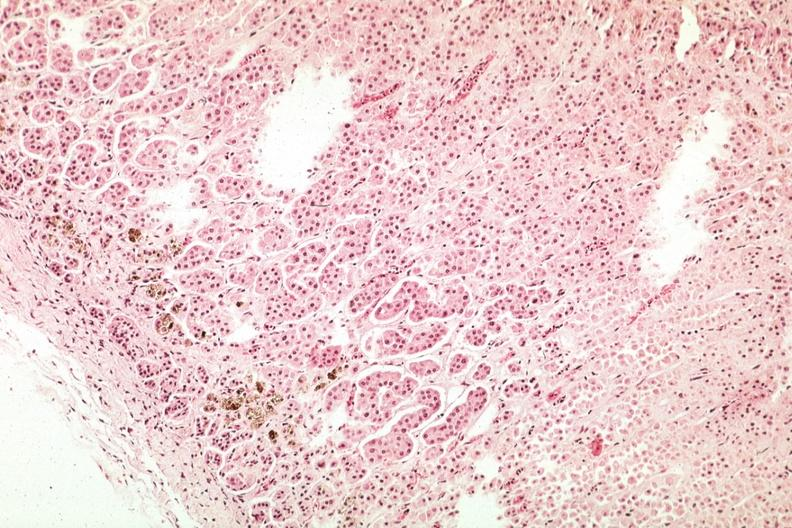what is present?
Answer the question using a single word or phrase. Endocrine 